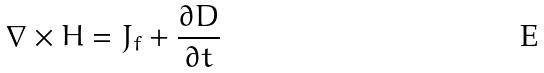<formula> <loc_0><loc_0><loc_500><loc_500>\nabla \times H = J _ { f } + { \frac { \partial D } { \partial t } }</formula> 